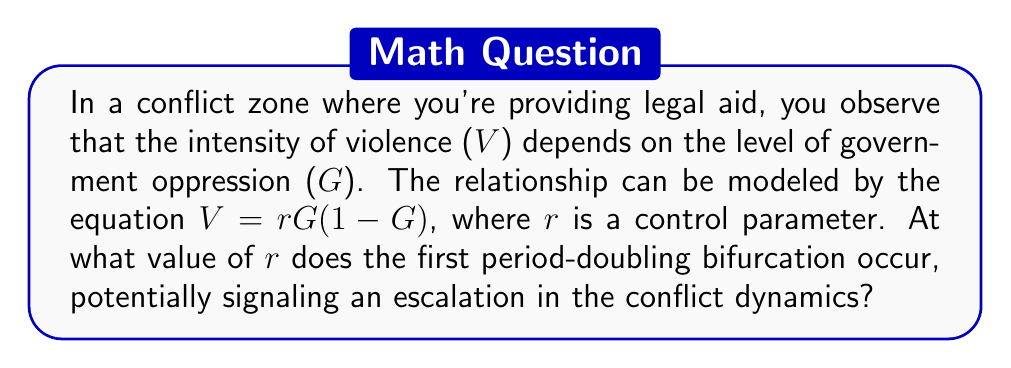Solve this math problem. To solve this problem, we need to understand the logistic map and its bifurcation properties:

1) The equation $V = rG(1-G)$ is a form of the logistic map, often used in chaos theory to model population dynamics and, in this case, conflict escalation.

2) As $r$ increases, the system undergoes a series of bifurcations, where the long-term behavior changes from a single fixed point to oscillations between multiple points.

3) The first period-doubling bifurcation occurs when the system transitions from a single stable fixed point to oscillation between two points.

4) For the logistic map, this first bifurcation occurs when:

   $$r = 1 + \sqrt{6} \approx 3.44949$$

5) This can be derived by analyzing the stability of the fixed points of the system:
   
   a) Find the fixed points by solving $G^* = rG^*(1-G^*)$
   b) Analyze the stability by calculating the derivative at these points
   c) Find the value of $r$ where the magnitude of this derivative equals -1

6) When $r$ exceeds this value, the conflict dynamics will begin to oscillate between two states, potentially indicating an escalation in the conflict's complexity.
Answer: $1 + \sqrt{6} \approx 3.44949$ 